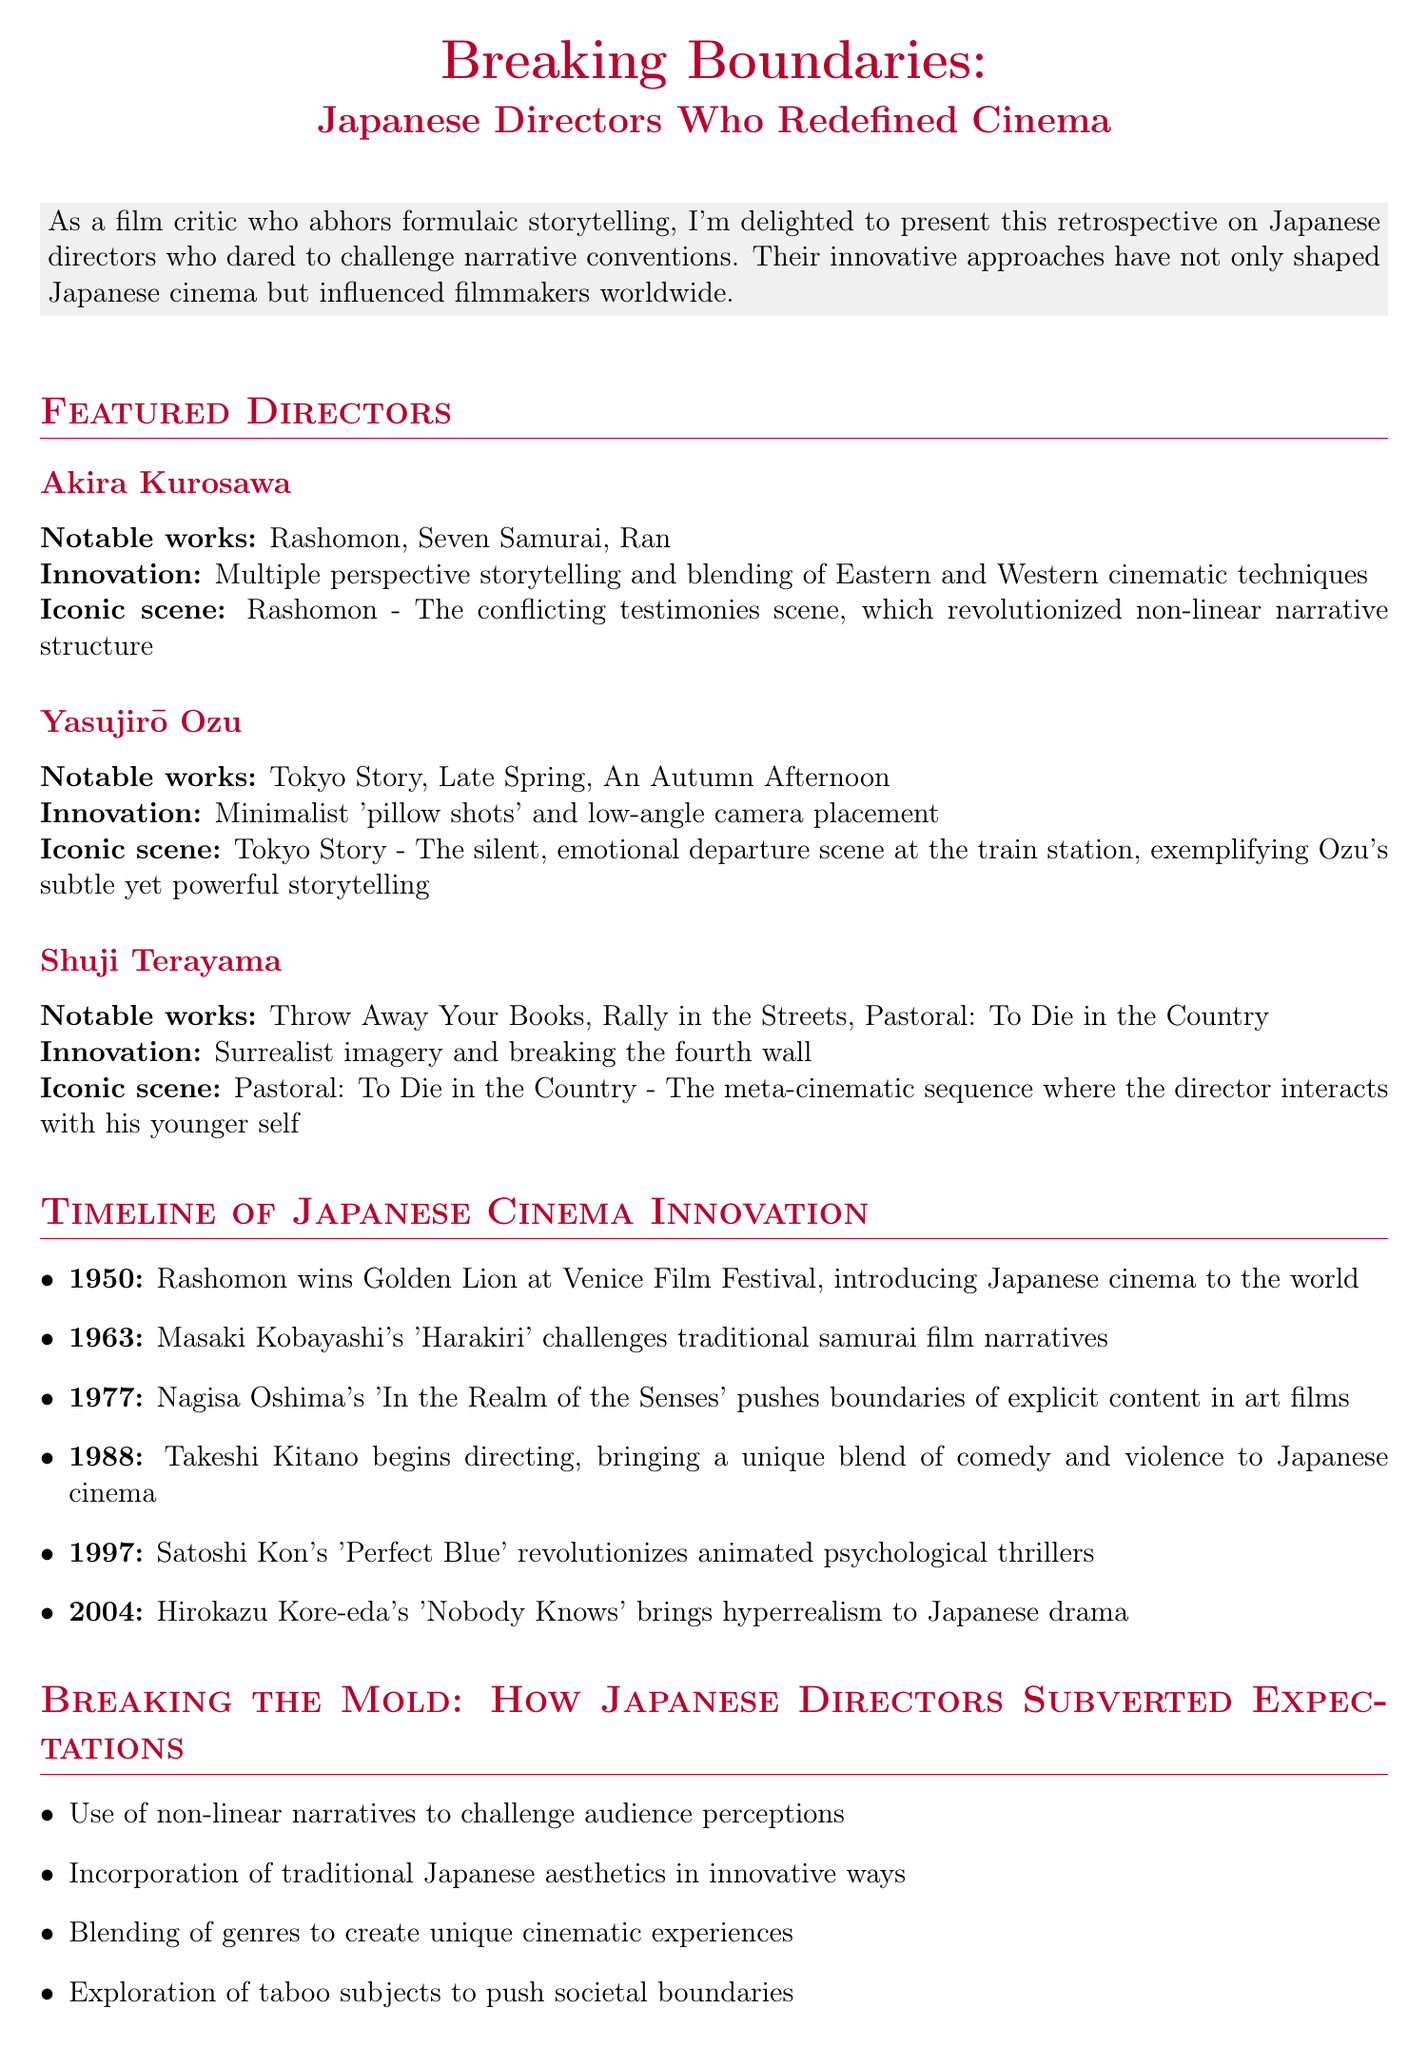What is the title of the retrospective? The title is mentioned at the beginning of the document and sets the theme for the content.
Answer: Breaking Boundaries: Japanese Directors Who Redefined Cinema Which director is associated with "Rashomon"? This is a specific work linked to Akira Kurosawa, noted for his innovative storytelling methods.
Answer: Akira Kurosawa What year did "Perfect Blue" come out? This date is included in the timeline to highlight significant innovations in Japanese cinema.
Answer: 1997 What is the notable innovation of Yasujirō Ozu? The document specifies Ozu's approach to cinematography that sets him apart.
Answer: Minimalist 'pillow shots' and low-angle camera placement Which iconic scene does Shuji Terayama create in "Pastoral: To Die in the Country"? This is found in the analysis of Terayama's works and describes a key moment in that film.
Answer: The meta-cinematic sequence where the director interacts with his younger self What unique aspect did Takeshi Kitano bring to Japanese cinema? The document discusses Kitano's distinct style that disrupts traditional cinematic forms.
Answer: A unique blend of comedy and violence In what year did "Rashomon" win the Golden Lion? This information is listed in the timeline as a significant milestone for Japanese cinema.
Answer: 1950 What is one key point about how Japanese directors subverted expectations? The document presents multiple key ideas that summarize their innovative approaches to storytelling.
Answer: Use of non-linear narratives to challenge audience perceptions 